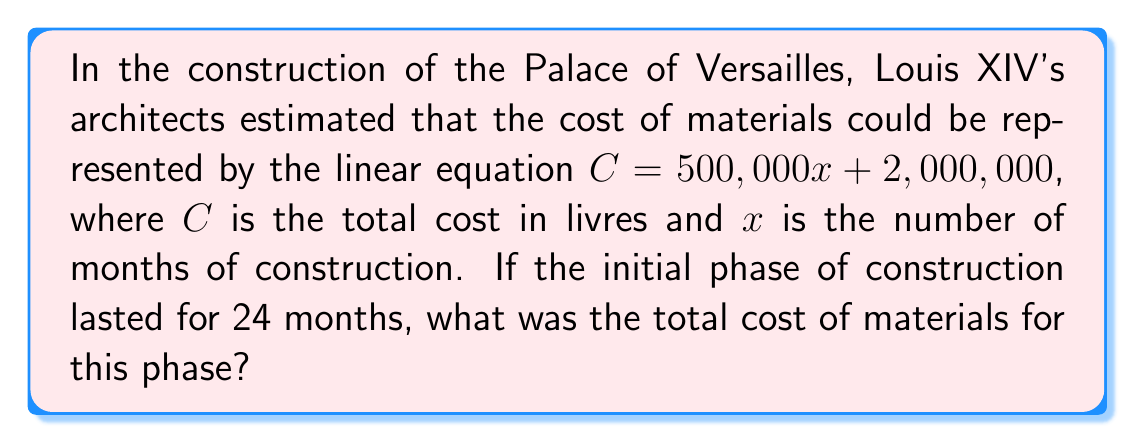Can you answer this question? Let's approach this step-by-step:

1) We are given the linear equation: $C = 500,000x + 2,000,000$
   Where $C$ is the total cost in livres and $x$ is the number of months.

2) We need to find the cost for 24 months of construction.
   So, we substitute $x = 24$ into our equation:

   $C = 500,000(24) + 2,000,000$

3) Let's solve this equation:
   $C = 12,000,000 + 2,000,000$
   $C = 14,000,000$

4) Therefore, the total cost of materials for the initial 24-month phase of construction was 14,000,000 livres.

This substantial sum reflects the grandeur and opulence that Louis XIV sought to display through the Palace of Versailles, a symbol of absolute monarchy and the power of France during his reign.
Answer: 14,000,000 livres 